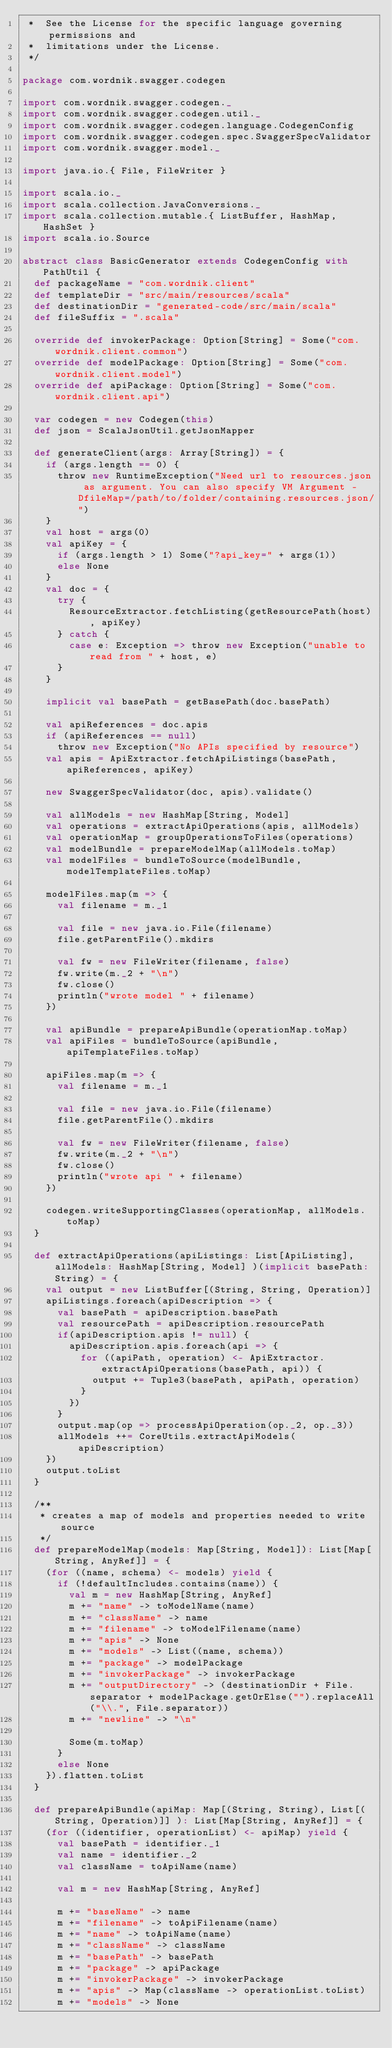<code> <loc_0><loc_0><loc_500><loc_500><_Scala_> *  See the License for the specific language governing permissions and
 *  limitations under the License.
 */

package com.wordnik.swagger.codegen

import com.wordnik.swagger.codegen._
import com.wordnik.swagger.codegen.util._
import com.wordnik.swagger.codegen.language.CodegenConfig
import com.wordnik.swagger.codegen.spec.SwaggerSpecValidator
import com.wordnik.swagger.model._

import java.io.{ File, FileWriter }

import scala.io._
import scala.collection.JavaConversions._
import scala.collection.mutable.{ ListBuffer, HashMap, HashSet }
import scala.io.Source

abstract class BasicGenerator extends CodegenConfig with PathUtil {
  def packageName = "com.wordnik.client"
  def templateDir = "src/main/resources/scala"
  def destinationDir = "generated-code/src/main/scala"
  def fileSuffix = ".scala"

  override def invokerPackage: Option[String] = Some("com.wordnik.client.common")
  override def modelPackage: Option[String] = Some("com.wordnik.client.model")
  override def apiPackage: Option[String] = Some("com.wordnik.client.api")

  var codegen = new Codegen(this)
  def json = ScalaJsonUtil.getJsonMapper

  def generateClient(args: Array[String]) = {
    if (args.length == 0) {
      throw new RuntimeException("Need url to resources.json as argument. You can also specify VM Argument -DfileMap=/path/to/folder/containing.resources.json/")
    }
    val host = args(0)
    val apiKey = {
      if (args.length > 1) Some("?api_key=" + args(1))
      else None
    }
    val doc = {
      try {
        ResourceExtractor.fetchListing(getResourcePath(host), apiKey)
      } catch {
        case e: Exception => throw new Exception("unable to read from " + host, e)
      }
    }

    implicit val basePath = getBasePath(doc.basePath)

    val apiReferences = doc.apis
    if (apiReferences == null)
      throw new Exception("No APIs specified by resource")
    val apis = ApiExtractor.fetchApiListings(basePath, apiReferences, apiKey)

    new SwaggerSpecValidator(doc, apis).validate()

    val allModels = new HashMap[String, Model]
    val operations = extractApiOperations(apis, allModels)
    val operationMap = groupOperationsToFiles(operations)
    val modelBundle = prepareModelMap(allModels.toMap)
    val modelFiles = bundleToSource(modelBundle, modelTemplateFiles.toMap)

    modelFiles.map(m => {
      val filename = m._1

      val file = new java.io.File(filename)
      file.getParentFile().mkdirs

      val fw = new FileWriter(filename, false)
      fw.write(m._2 + "\n")
      fw.close()
      println("wrote model " + filename)
    })

    val apiBundle = prepareApiBundle(operationMap.toMap)
    val apiFiles = bundleToSource(apiBundle, apiTemplateFiles.toMap)

    apiFiles.map(m => {
      val filename = m._1

      val file = new java.io.File(filename)
      file.getParentFile().mkdirs

      val fw = new FileWriter(filename, false)
      fw.write(m._2 + "\n")
      fw.close()
      println("wrote api " + filename)
    })

    codegen.writeSupportingClasses(operationMap, allModels.toMap)
  }

  def extractApiOperations(apiListings: List[ApiListing], allModels: HashMap[String, Model] )(implicit basePath:String) = {
    val output = new ListBuffer[(String, String, Operation)]
    apiListings.foreach(apiDescription => {
      val basePath = apiDescription.basePath
      val resourcePath = apiDescription.resourcePath
      if(apiDescription.apis != null) {
        apiDescription.apis.foreach(api => {
          for ((apiPath, operation) <- ApiExtractor.extractApiOperations(basePath, api)) {
            output += Tuple3(basePath, apiPath, operation)
          }
        })
      }
      output.map(op => processApiOperation(op._2, op._3))
      allModels ++= CoreUtils.extractApiModels(apiDescription)
    })
    output.toList
  }

  /**
   * creates a map of models and properties needed to write source
   */
  def prepareModelMap(models: Map[String, Model]): List[Map[String, AnyRef]] = {
    (for ((name, schema) <- models) yield {
      if (!defaultIncludes.contains(name)) {
        val m = new HashMap[String, AnyRef]
        m += "name" -> toModelName(name)
        m += "className" -> name
        m += "filename" -> toModelFilename(name)
        m += "apis" -> None
        m += "models" -> List((name, schema))
        m += "package" -> modelPackage
        m += "invokerPackage" -> invokerPackage
        m += "outputDirectory" -> (destinationDir + File.separator + modelPackage.getOrElse("").replaceAll("\\.", File.separator))
        m += "newline" -> "\n"

        Some(m.toMap)
      }
      else None
    }).flatten.toList
  }

  def prepareApiBundle(apiMap: Map[(String, String), List[(String, Operation)]] ): List[Map[String, AnyRef]] = {
    (for ((identifier, operationList) <- apiMap) yield {
      val basePath = identifier._1
      val name = identifier._2
      val className = toApiName(name)

      val m = new HashMap[String, AnyRef]

      m += "baseName" -> name
      m += "filename" -> toApiFilename(name)
      m += "name" -> toApiName(name)
      m += "className" -> className
      m += "basePath" -> basePath
      m += "package" -> apiPackage
      m += "invokerPackage" -> invokerPackage
      m += "apis" -> Map(className -> operationList.toList)
      m += "models" -> None</code> 